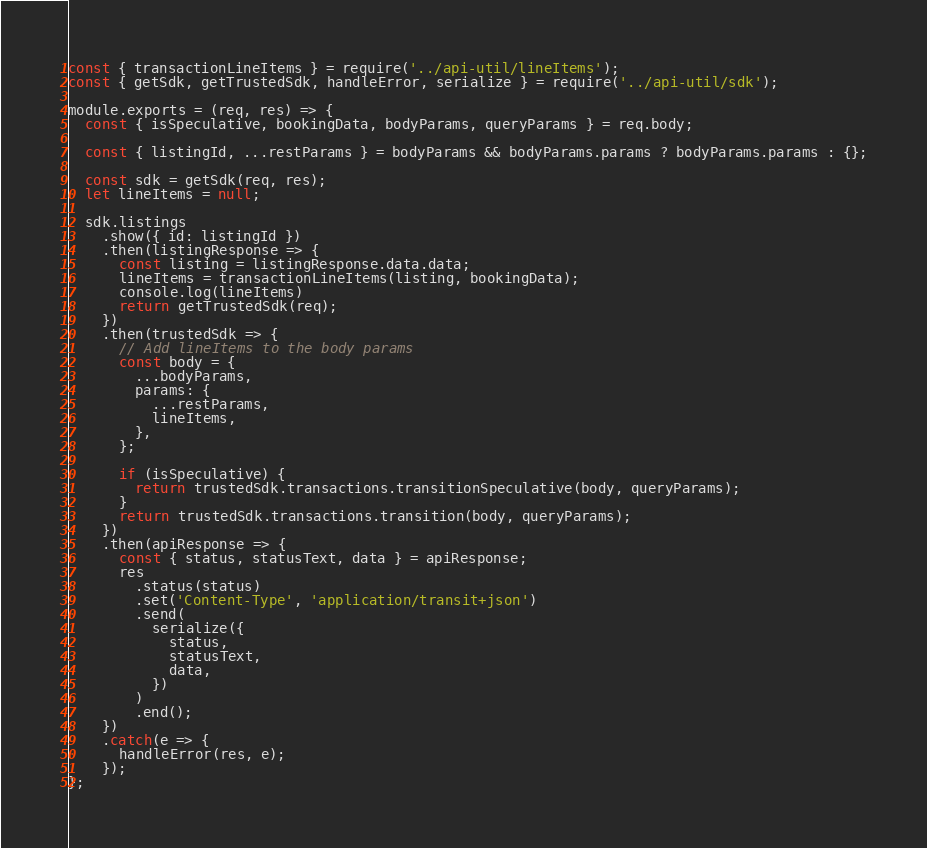<code> <loc_0><loc_0><loc_500><loc_500><_JavaScript_>const { transactionLineItems } = require('../api-util/lineItems');
const { getSdk, getTrustedSdk, handleError, serialize } = require('../api-util/sdk');

module.exports = (req, res) => {
  const { isSpeculative, bookingData, bodyParams, queryParams } = req.body;

  const { listingId, ...restParams } = bodyParams && bodyParams.params ? bodyParams.params : {};

  const sdk = getSdk(req, res);
  let lineItems = null;

  sdk.listings
    .show({ id: listingId })
    .then(listingResponse => {
      const listing = listingResponse.data.data;
      lineItems = transactionLineItems(listing, bookingData);
      console.log(lineItems)
      return getTrustedSdk(req);
    })
    .then(trustedSdk => {
      // Add lineItems to the body params
      const body = {
        ...bodyParams,
        params: {
          ...restParams,
          lineItems,
        },
      };

      if (isSpeculative) {
        return trustedSdk.transactions.transitionSpeculative(body, queryParams);
      }
      return trustedSdk.transactions.transition(body, queryParams);
    })
    .then(apiResponse => {
      const { status, statusText, data } = apiResponse;
      res
        .status(status)
        .set('Content-Type', 'application/transit+json')
        .send(
          serialize({
            status,
            statusText,
            data,
          })
        )
        .end();
    })
    .catch(e => {
      handleError(res, e);
    });
};
</code> 